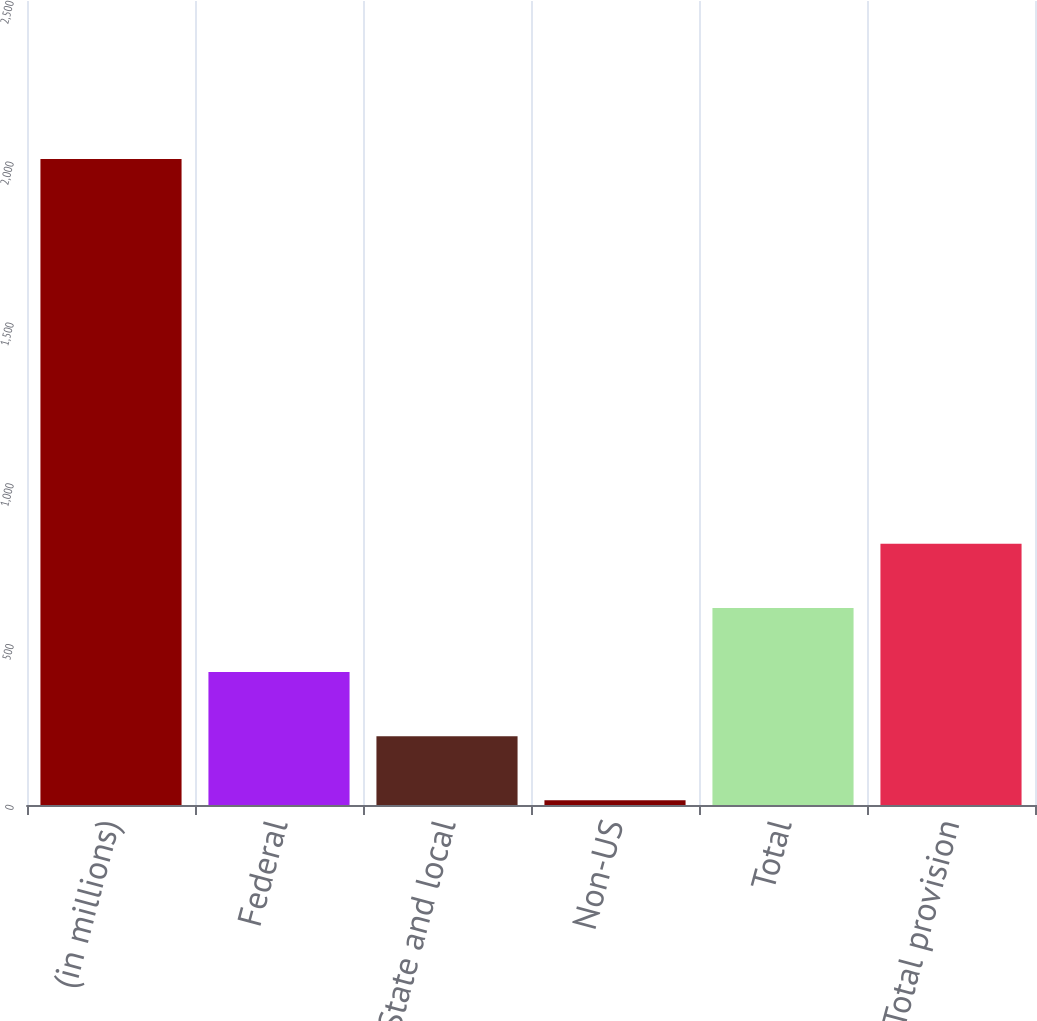<chart> <loc_0><loc_0><loc_500><loc_500><bar_chart><fcel>(in millions)<fcel>Federal<fcel>State and local<fcel>Non-US<fcel>Total<fcel>Total provision<nl><fcel>2009<fcel>413.32<fcel>213.86<fcel>14.4<fcel>612.78<fcel>812.24<nl></chart> 